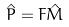<formula> <loc_0><loc_0><loc_500><loc_500>\hat { P } = F \hat { M }</formula> 